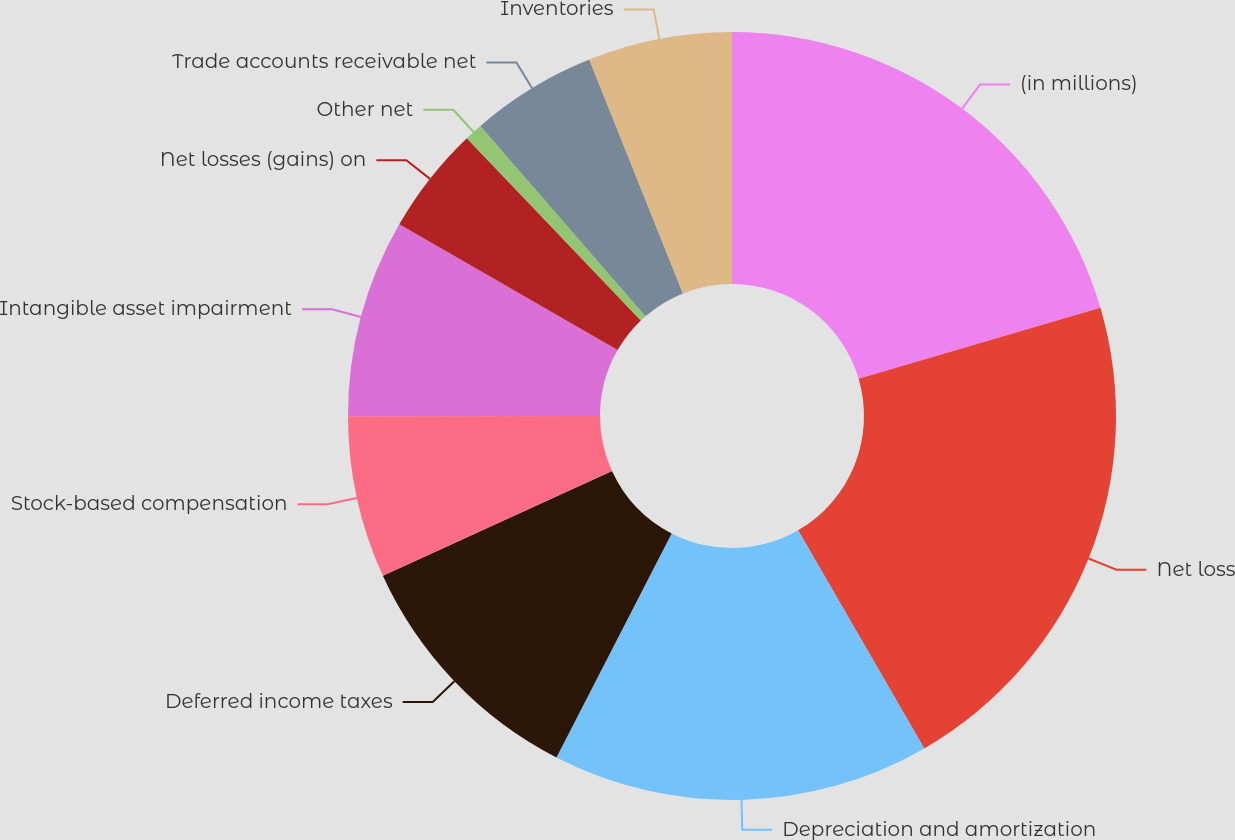<chart> <loc_0><loc_0><loc_500><loc_500><pie_chart><fcel>(in millions)<fcel>Net loss<fcel>Depreciation and amortization<fcel>Deferred income taxes<fcel>Stock-based compensation<fcel>Intangible asset impairment<fcel>Net losses (gains) on<fcel>Other net<fcel>Trade accounts receivable net<fcel>Inventories<nl><fcel>20.45%<fcel>21.2%<fcel>15.9%<fcel>10.61%<fcel>6.82%<fcel>8.33%<fcel>4.55%<fcel>0.76%<fcel>5.31%<fcel>6.06%<nl></chart> 